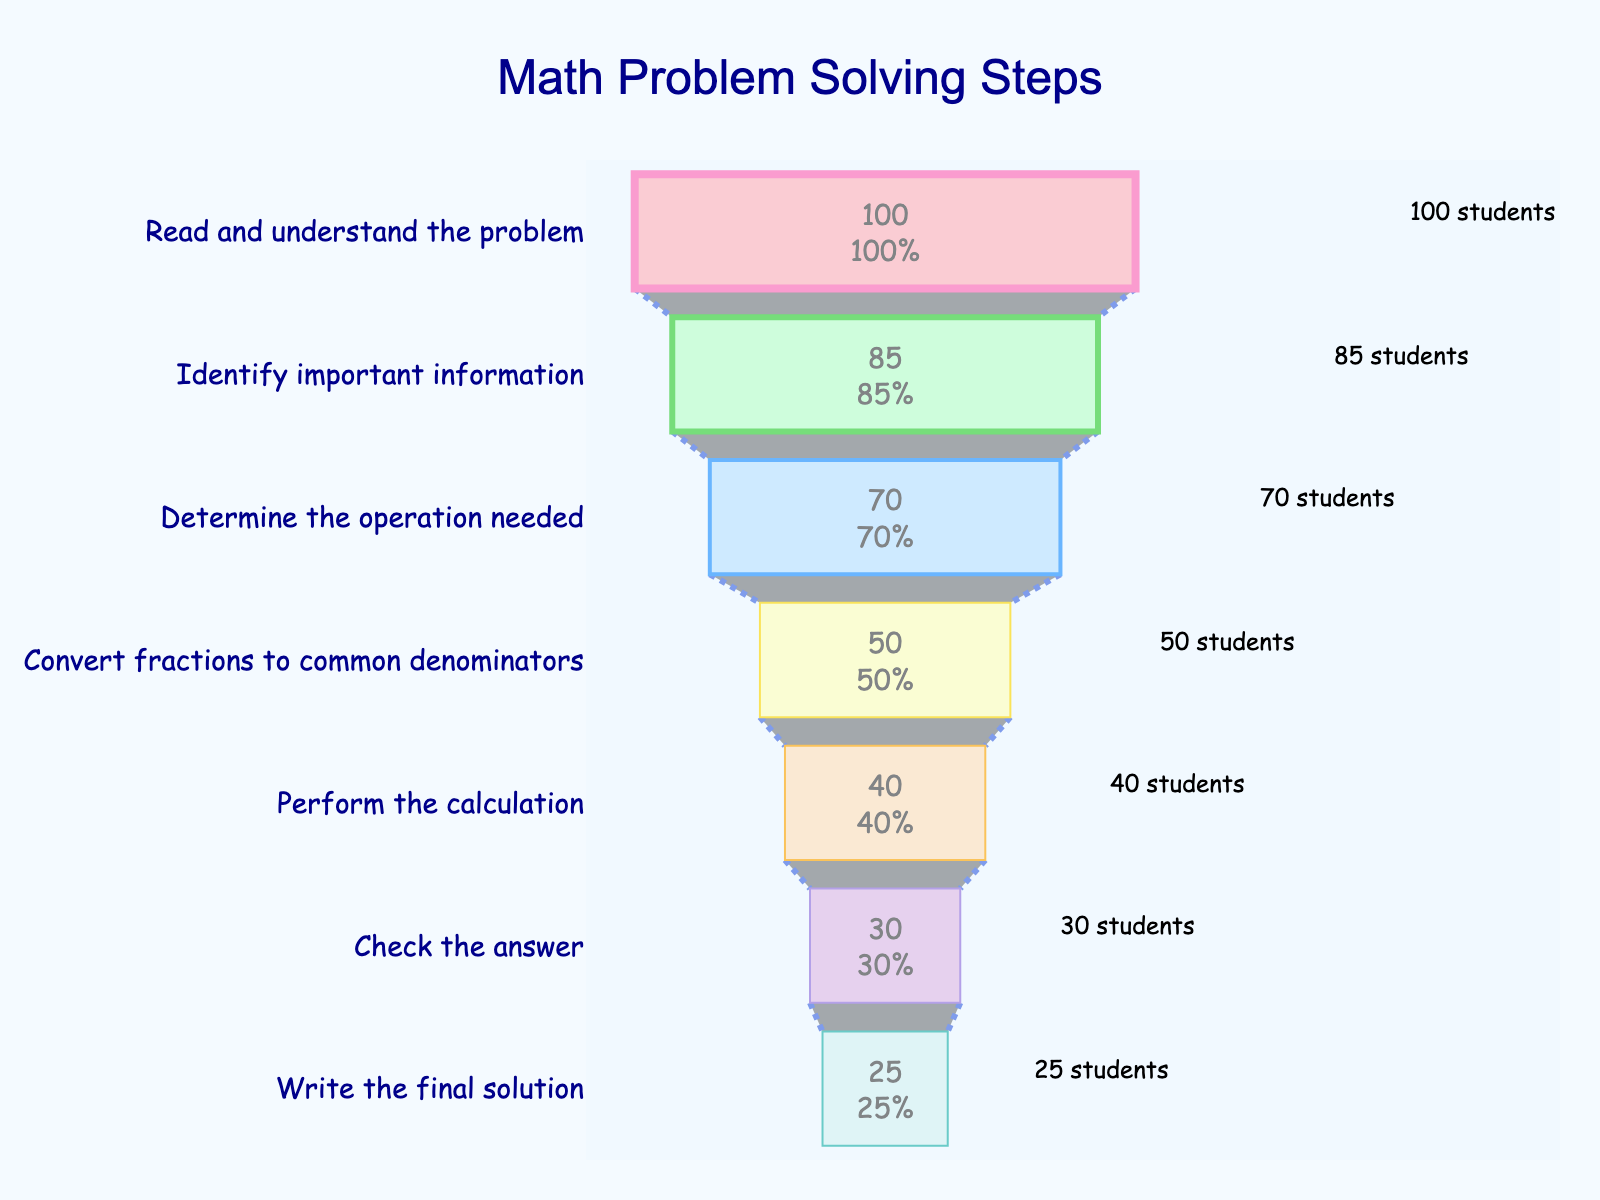What is the title of the funnel chart? The title is prominently displayed at the top center of the chart. It reads "Math Problem Solving Steps".
Answer: Math Problem Solving Steps How many stages are there in the funnel chart? Count the number of stages listed vertically on the y-axis. There are seven stages in the funnel chart.
Answer: Seven stages Which stage has the lowest number of students remaining? The stage with the lowest bar on the x-axis (left to right) represents the lowest number of students remaining, which is "Write the final solution" with 25 students.
Answer: Write the final solution What percentage of students successfully performed the calculation? Look at the text inside the section labeled "Perform the calculation". It shows 40 students remaining, which is 40% of the initial 100 students.
Answer: 40% How many students failed to convert fractions to common denominators? Subtract the number of students remaining in this stage (50) from the initial number of students (100). 100 - 50 = 50 students failed.
Answer: 50 students What is the difference in the number of students remaining between 'Identify important information' and 'Perform the calculation'? Subtract the number of students remaining in each stage: 85 (Identify important information) - 40 (Perform the calculation) = 45.
Answer: 45 students Which stage has the highest loss of students compared to the previous stage? Calculate the difference between each stage. The largest drop is between "Determine the operation needed" (70) and "Convert fractions to common denominators" (50): 70 - 50 = 20.
Answer: Convert fractions to common denominators How many students checked their answer? Look at the text inside the section labeled "Check the answer". It shows 30 students remaining.
Answer: 30 students What fraction of the initial student group successfully wrote the final solution? Divide the number of students who wrote the final solution (25) by the initial number of students (100): 25/100 = 1/4 or 0.25.
Answer: 1/4 or 0.25 Which stage has the same number of students remaining as the percentage value? Look at the stages, "Check the answer" has 30 students remaining which matches its percentage value of 30%.
Answer: Check the answer 